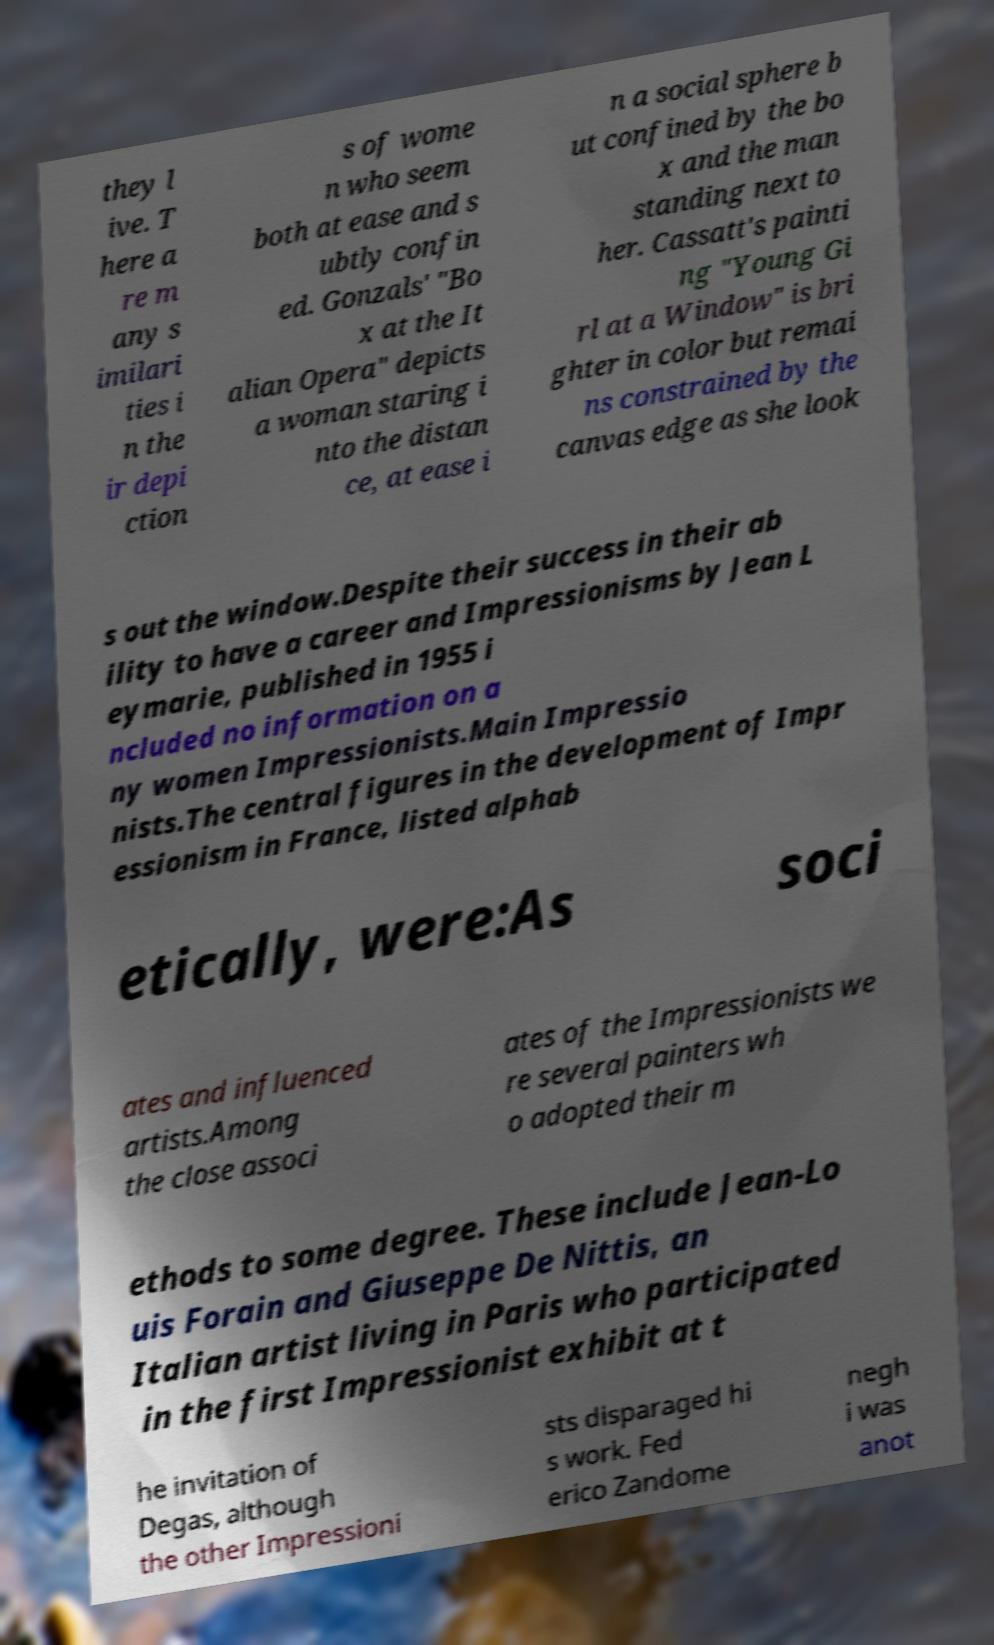What messages or text are displayed in this image? I need them in a readable, typed format. they l ive. T here a re m any s imilari ties i n the ir depi ction s of wome n who seem both at ease and s ubtly confin ed. Gonzals' "Bo x at the It alian Opera" depicts a woman staring i nto the distan ce, at ease i n a social sphere b ut confined by the bo x and the man standing next to her. Cassatt's painti ng "Young Gi rl at a Window" is bri ghter in color but remai ns constrained by the canvas edge as she look s out the window.Despite their success in their ab ility to have a career and Impressionisms by Jean L eymarie, published in 1955 i ncluded no information on a ny women Impressionists.Main Impressio nists.The central figures in the development of Impr essionism in France, listed alphab etically, were:As soci ates and influenced artists.Among the close associ ates of the Impressionists we re several painters wh o adopted their m ethods to some degree. These include Jean-Lo uis Forain and Giuseppe De Nittis, an Italian artist living in Paris who participated in the first Impressionist exhibit at t he invitation of Degas, although the other Impressioni sts disparaged hi s work. Fed erico Zandome negh i was anot 